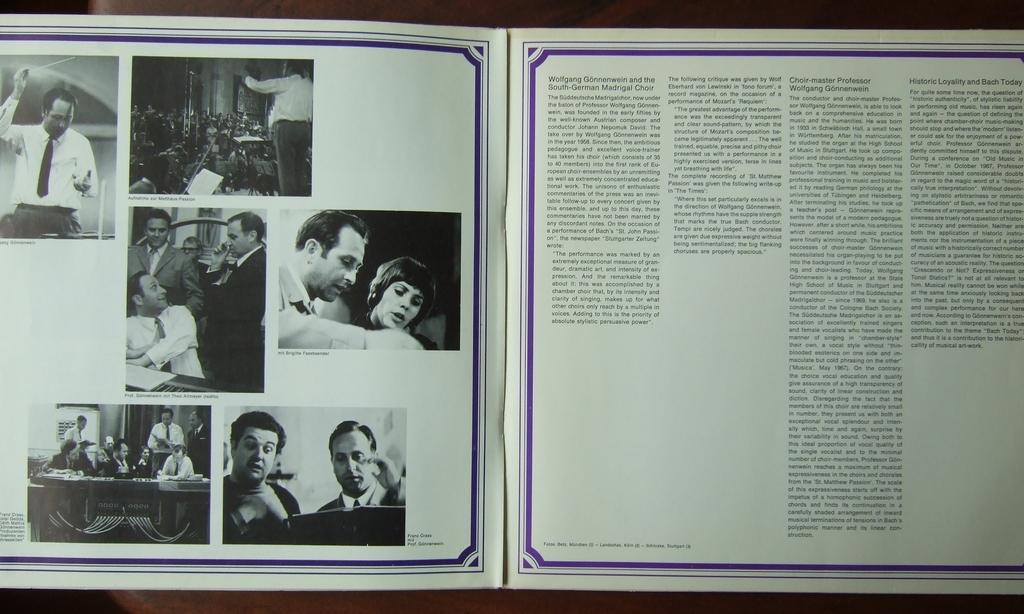What first name is mentioned at the top of the right page?
Make the answer very short. Wolfgang. Which choir is featured on the first column?
Your answer should be compact. Unanswerable. 